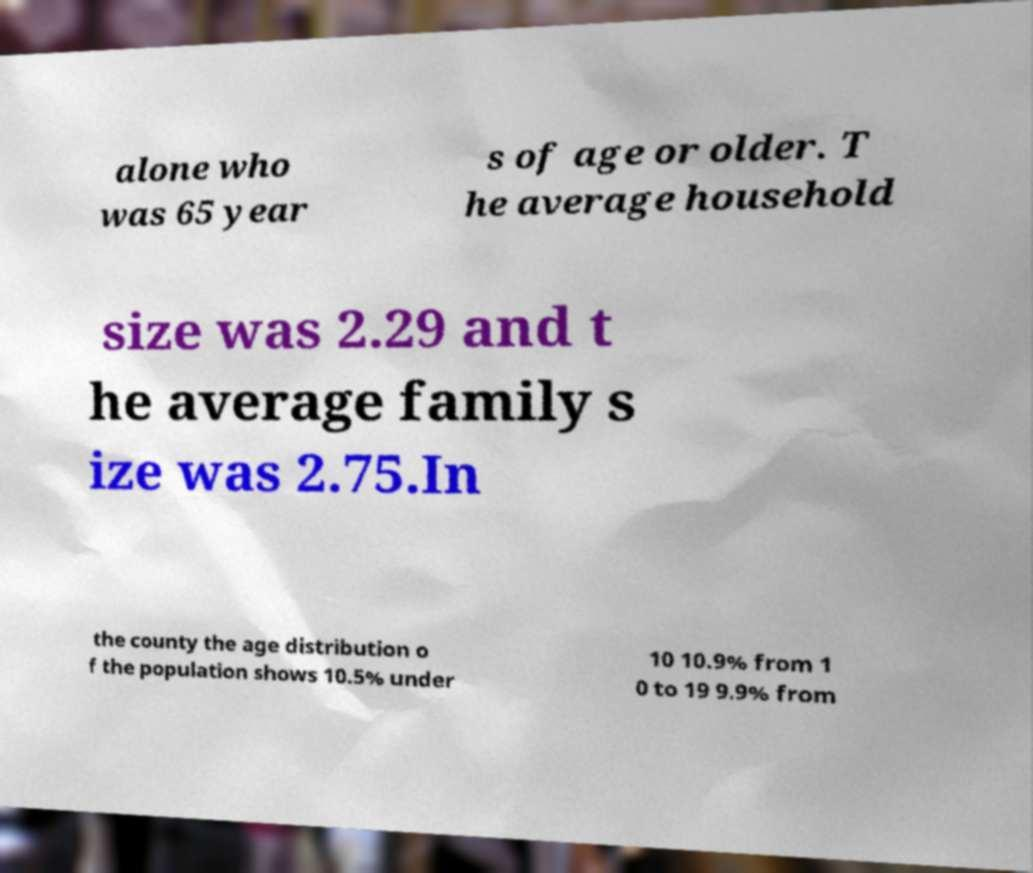For documentation purposes, I need the text within this image transcribed. Could you provide that? alone who was 65 year s of age or older. T he average household size was 2.29 and t he average family s ize was 2.75.In the county the age distribution o f the population shows 10.5% under 10 10.9% from 1 0 to 19 9.9% from 